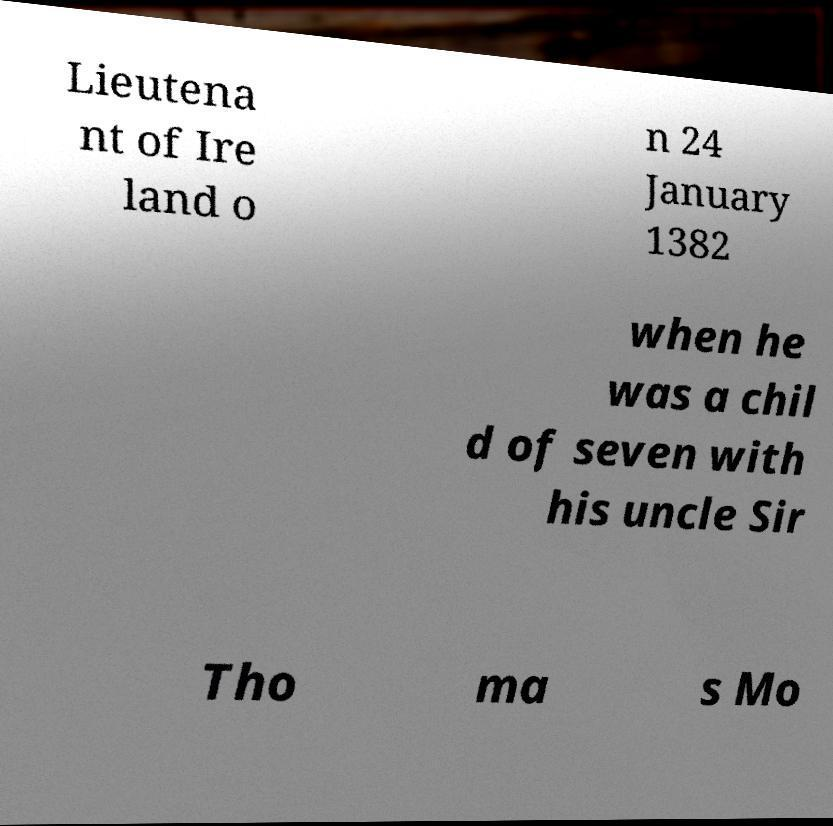What messages or text are displayed in this image? I need them in a readable, typed format. Lieutena nt of Ire land o n 24 January 1382 when he was a chil d of seven with his uncle Sir Tho ma s Mo 